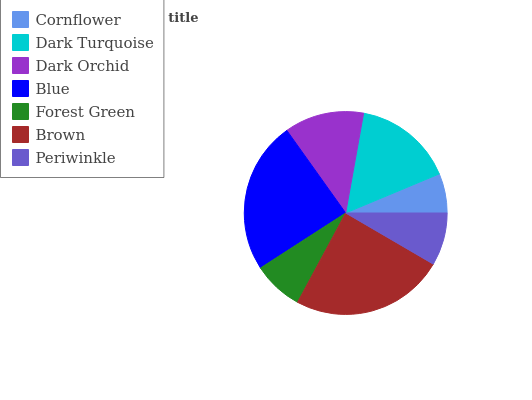Is Cornflower the minimum?
Answer yes or no. Yes. Is Brown the maximum?
Answer yes or no. Yes. Is Dark Turquoise the minimum?
Answer yes or no. No. Is Dark Turquoise the maximum?
Answer yes or no. No. Is Dark Turquoise greater than Cornflower?
Answer yes or no. Yes. Is Cornflower less than Dark Turquoise?
Answer yes or no. Yes. Is Cornflower greater than Dark Turquoise?
Answer yes or no. No. Is Dark Turquoise less than Cornflower?
Answer yes or no. No. Is Dark Orchid the high median?
Answer yes or no. Yes. Is Dark Orchid the low median?
Answer yes or no. Yes. Is Brown the high median?
Answer yes or no. No. Is Blue the low median?
Answer yes or no. No. 